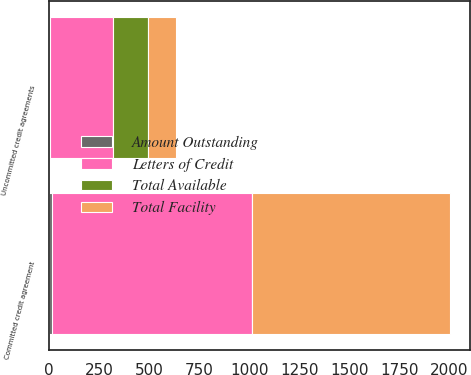Convert chart to OTSL. <chart><loc_0><loc_0><loc_500><loc_500><stacked_bar_chart><ecel><fcel>Committed credit agreement<fcel>Uncommitted credit agreements<nl><fcel>Letters of Credit<fcel>1000<fcel>317.2<nl><fcel>Total Available<fcel>0<fcel>172.1<nl><fcel>Amount Outstanding<fcel>15.1<fcel>3.3<nl><fcel>Total Facility<fcel>984.9<fcel>141.8<nl></chart> 